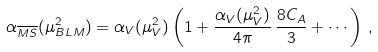<formula> <loc_0><loc_0><loc_500><loc_500>\alpha _ { \overline { M S } } ( \mu _ { B L M } ^ { 2 } ) = \alpha _ { V } ( \mu _ { V } ^ { 2 } ) \left ( 1 + \frac { \alpha _ { V } ( \mu _ { V } ^ { 2 } ) } { 4 \pi } \, \frac { 8 C _ { A } } { 3 } + \cdots \right ) \, ,</formula> 